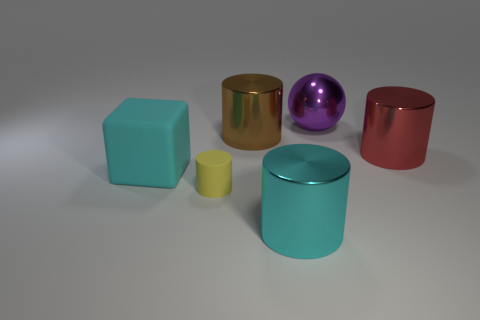Are there more shiny things that are to the left of the red cylinder than metallic things that are right of the brown cylinder?
Give a very brief answer. No. How many cyan rubber objects have the same size as the metallic ball?
Your response must be concise. 1. Is the number of big cyan cylinders in front of the big rubber thing less than the number of big cyan things to the left of the big red cylinder?
Ensure brevity in your answer.  Yes. Are there any other red things of the same shape as the red thing?
Offer a very short reply. No. Is the large brown thing the same shape as the large red thing?
Offer a very short reply. Yes. What number of large objects are either red shiny cylinders or cyan cubes?
Ensure brevity in your answer.  2. Is the number of small rubber things greater than the number of big blue cubes?
Your answer should be very brief. Yes. There is a object that is made of the same material as the cyan cube; what is its size?
Offer a terse response. Small. There is a cylinder on the right side of the cyan cylinder; is it the same size as the matte thing in front of the cyan rubber object?
Your answer should be very brief. No. What number of objects are either big cyan things on the right side of the yellow cylinder or brown shiny objects?
Provide a succinct answer. 2. 